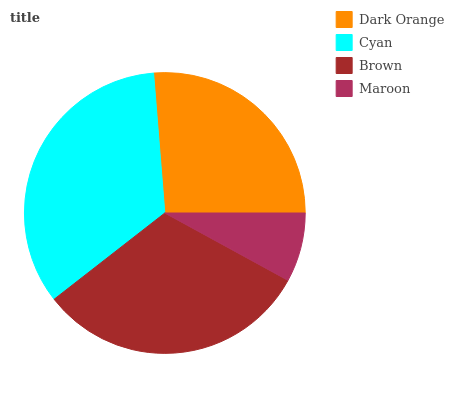Is Maroon the minimum?
Answer yes or no. Yes. Is Cyan the maximum?
Answer yes or no. Yes. Is Brown the minimum?
Answer yes or no. No. Is Brown the maximum?
Answer yes or no. No. Is Cyan greater than Brown?
Answer yes or no. Yes. Is Brown less than Cyan?
Answer yes or no. Yes. Is Brown greater than Cyan?
Answer yes or no. No. Is Cyan less than Brown?
Answer yes or no. No. Is Brown the high median?
Answer yes or no. Yes. Is Dark Orange the low median?
Answer yes or no. Yes. Is Dark Orange the high median?
Answer yes or no. No. Is Brown the low median?
Answer yes or no. No. 